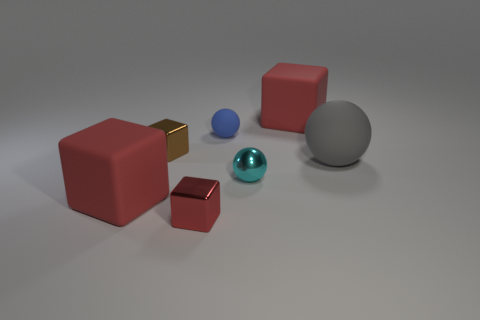There is a tiny matte sphere; how many large gray spheres are behind it?
Provide a short and direct response. 0. What number of gray balls are there?
Offer a very short reply. 1. Is the size of the blue thing the same as the cyan metallic thing?
Offer a terse response. Yes. There is a shiny cube that is in front of the small metal thing to the right of the small red block; are there any red objects that are behind it?
Keep it short and to the point. Yes. There is a tiny blue thing that is the same shape as the cyan thing; what is it made of?
Your answer should be very brief. Rubber. The small ball to the left of the cyan metal sphere is what color?
Provide a short and direct response. Blue. What is the size of the blue rubber sphere?
Offer a terse response. Small. Does the blue thing have the same size as the red thing that is behind the gray rubber ball?
Give a very brief answer. No. There is a sphere behind the metallic block that is left of the small red shiny cube to the left of the metal ball; what is its color?
Offer a very short reply. Blue. Does the big red block behind the gray sphere have the same material as the tiny red block?
Offer a very short reply. No. 